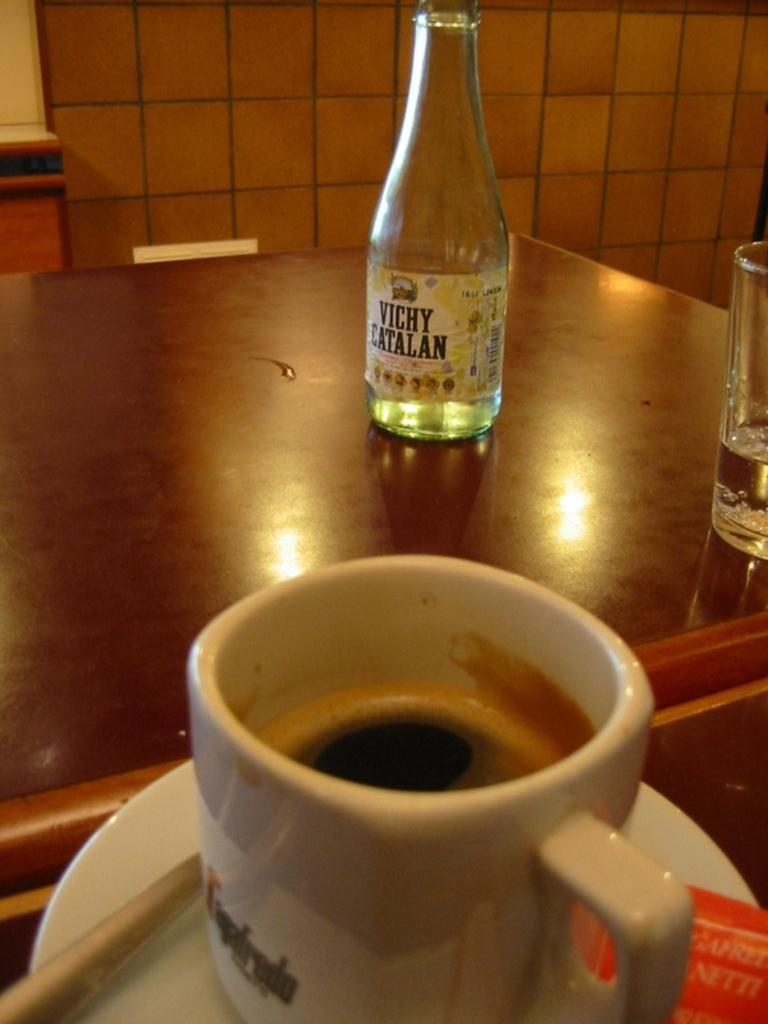<image>
Relay a brief, clear account of the picture shown. Vichy Catalan empty bottle sitting behind a coffee cup and next to a glass of water. 